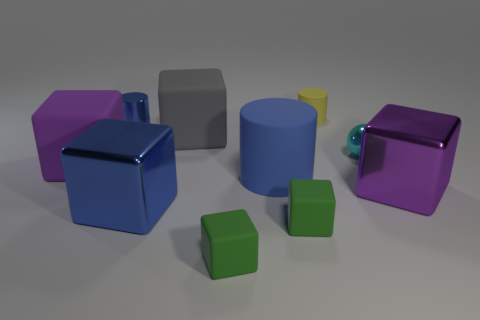Subtract all tiny blue cylinders. How many cylinders are left? 2 Subtract all red balls. How many blue cubes are left? 1 Subtract all green cubes. How many cubes are left? 4 Subtract 1 cubes. How many cubes are left? 5 Subtract all cyan shiny objects. Subtract all small yellow objects. How many objects are left? 8 Add 4 matte blocks. How many matte blocks are left? 8 Add 5 purple metal things. How many purple metal things exist? 6 Subtract 0 brown cylinders. How many objects are left? 10 Subtract all cylinders. How many objects are left? 7 Subtract all brown spheres. Subtract all red cylinders. How many spheres are left? 1 